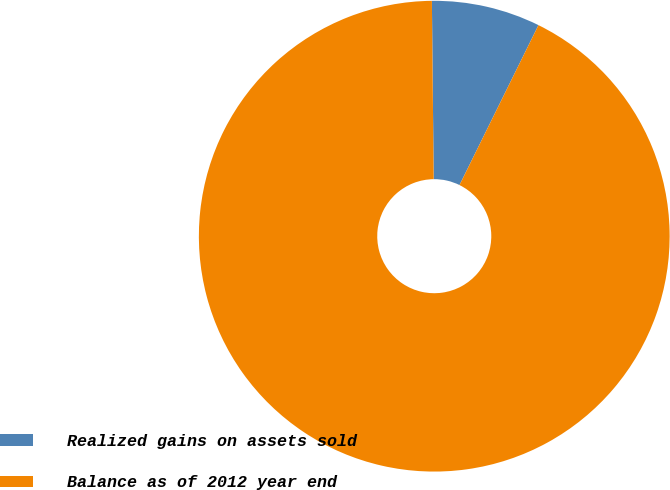Convert chart. <chart><loc_0><loc_0><loc_500><loc_500><pie_chart><fcel>Realized gains on assets sold<fcel>Balance as of 2012 year end<nl><fcel>7.46%<fcel>92.54%<nl></chart> 